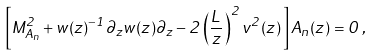<formula> <loc_0><loc_0><loc_500><loc_500>\left [ M _ { A _ { n } } ^ { 2 } + w ( z ) ^ { - 1 } \partial _ { z } w ( z ) \partial _ { z } - 2 \left ( \frac { L } { z } \right ) ^ { 2 } v ^ { 2 } ( z ) \, \right ] A _ { n } ( z ) = 0 \, ,</formula> 